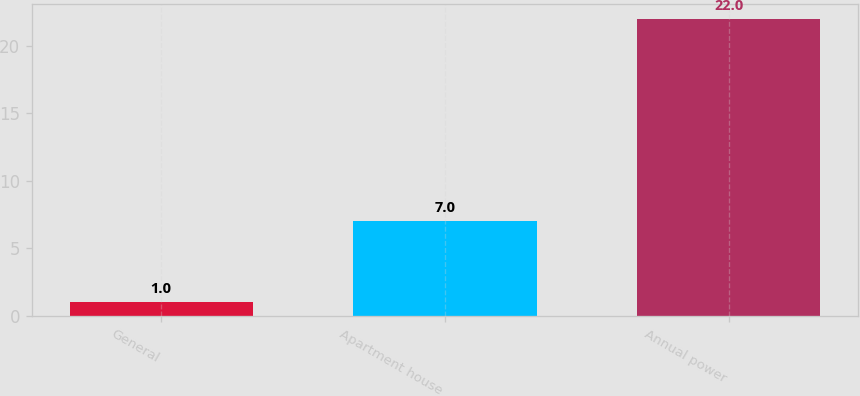<chart> <loc_0><loc_0><loc_500><loc_500><bar_chart><fcel>General<fcel>Apartment house<fcel>Annual power<nl><fcel>1<fcel>7<fcel>22<nl></chart> 